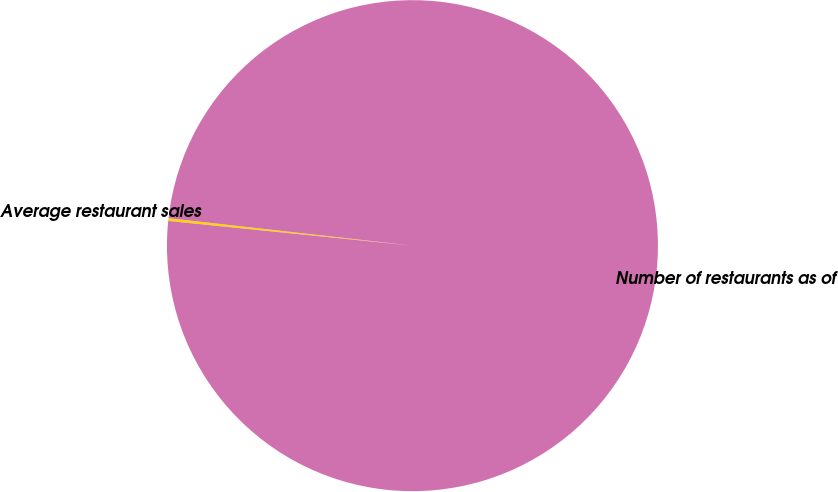Convert chart. <chart><loc_0><loc_0><loc_500><loc_500><pie_chart><fcel>Average restaurant sales<fcel>Number of restaurants as of<nl><fcel>0.18%<fcel>99.82%<nl></chart> 